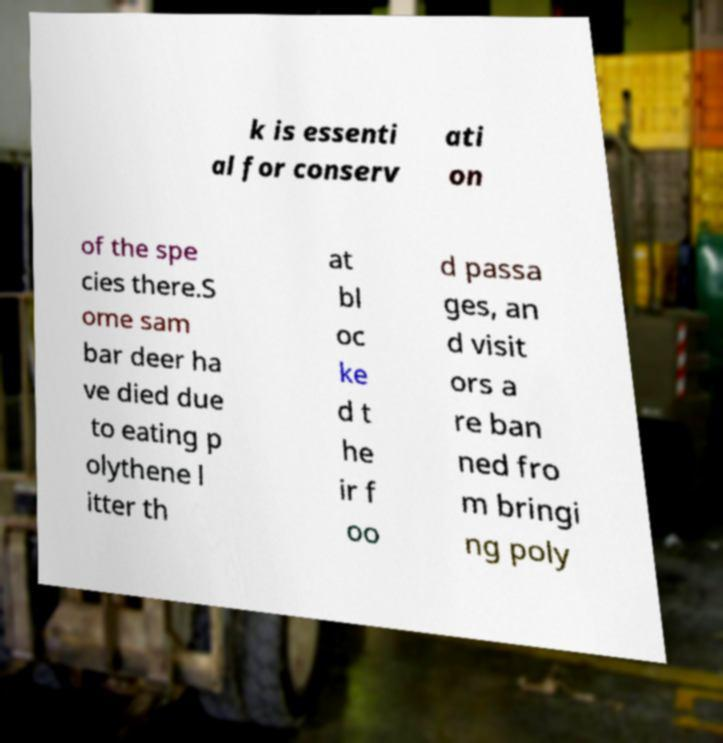Please read and relay the text visible in this image. What does it say? k is essenti al for conserv ati on of the spe cies there.S ome sam bar deer ha ve died due to eating p olythene l itter th at bl oc ke d t he ir f oo d passa ges, an d visit ors a re ban ned fro m bringi ng poly 